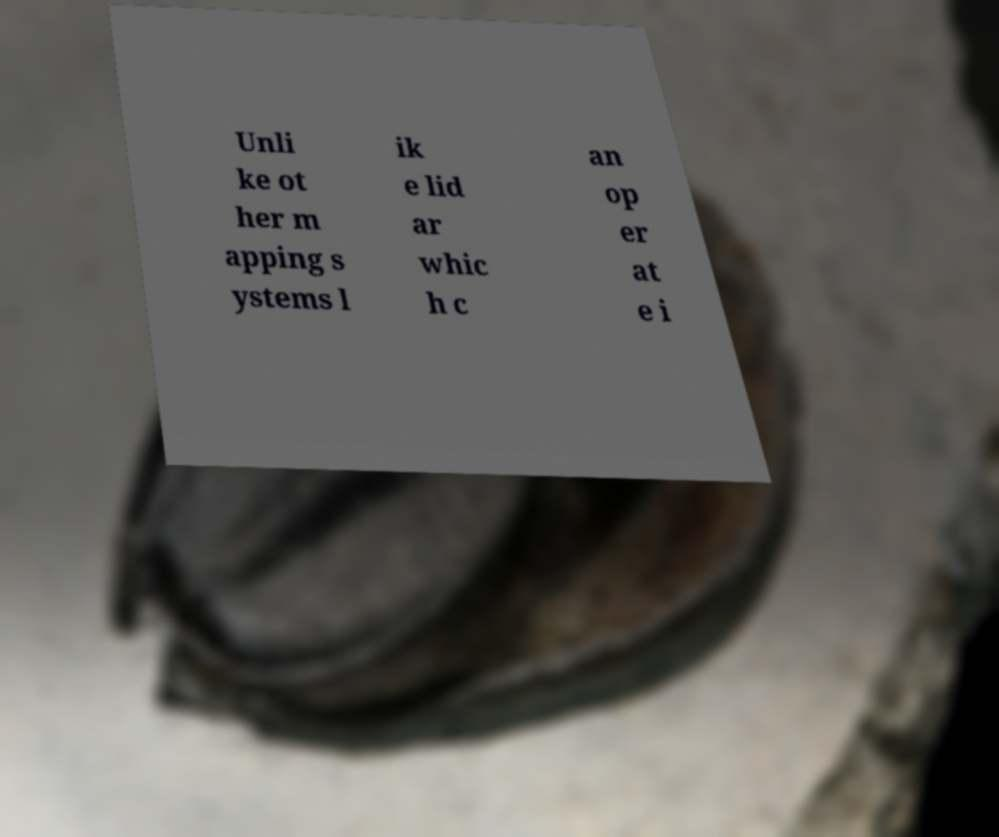Could you extract and type out the text from this image? Unli ke ot her m apping s ystems l ik e lid ar whic h c an op er at e i 